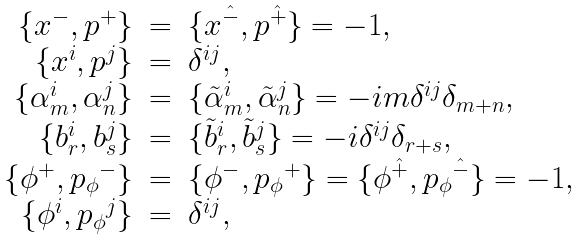Convert formula to latex. <formula><loc_0><loc_0><loc_500><loc_500>\begin{array} { r c l } \{ x ^ { - } , p ^ { + } \} & = & \{ x ^ { \hat { - } } , p ^ { \hat { + } } \} = - 1 , \\ \{ x ^ { i } , p ^ { j } \} & = & \delta ^ { i j } , \\ \{ \alpha ^ { i } _ { m } , \alpha ^ { j } _ { n } \} & = & \{ \tilde { \alpha } ^ { i } _ { m } , \tilde { \alpha } ^ { j } _ { n } \} = - i m \delta ^ { i j } \delta _ { m + n } , \\ \{ b ^ { i } _ { r } , b ^ { j } _ { s } \} & = & \{ \tilde { b } ^ { i } _ { r } , \tilde { b } ^ { j } _ { s } \} = - i \delta ^ { i j } \delta _ { r + s } , \\ \{ \phi ^ { + } , { p _ { \phi } } ^ { - } \} & = & \{ \phi ^ { - } , { p _ { \phi } } ^ { + } \} = \{ \phi ^ { \hat { + } } , { p _ { \phi } } ^ { \hat { - } } \} = - 1 , \\ \{ \phi ^ { i } , { p _ { \phi } } ^ { j } \} & = & \delta ^ { i j } , \end{array}</formula> 